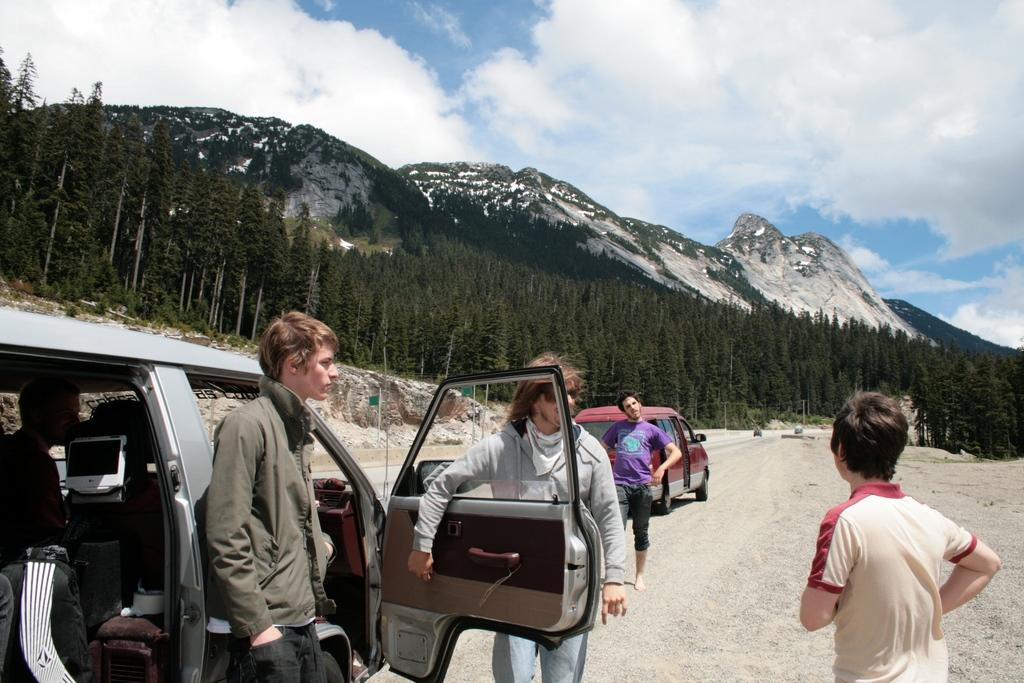How many persons are standing near the vehicle in the image? There are three persons standing near the vehicle in the image. What type of natural vegetation can be seen in the image? There are trees in the image. What type of natural geological formation can be seen in the image? There are mountains in the image. What part of the natural environment is visible in the image? The sky is visible in the image. What type of jeans is the vehicle wearing in the image? The vehicle is not a living being and therefore cannot wear jeans. What trick is being performed by the trees in the image? There is no trick being performed by the trees in the image; they are simply standing in the natural environment. 